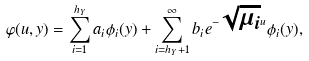<formula> <loc_0><loc_0><loc_500><loc_500>\varphi ( u , y ) = \sum ^ { h _ { Y } } _ { i = 1 } a _ { i } \phi _ { i } ( y ) + \sum ^ { \infty } _ { i = h _ { Y } + 1 } b _ { i } e ^ { - \sqrt { \mu _ { i } } u } \phi _ { i } ( y ) ,</formula> 